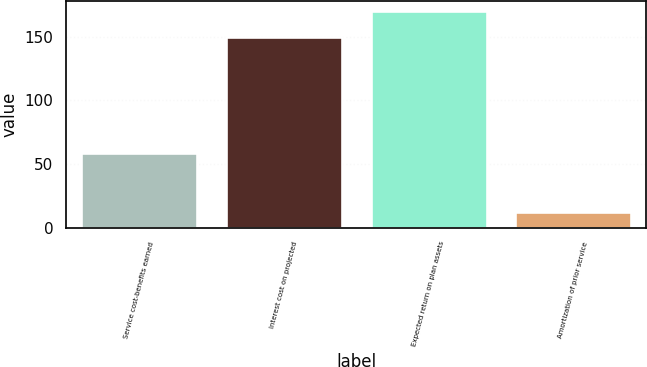<chart> <loc_0><loc_0><loc_500><loc_500><bar_chart><fcel>Service cost-benefits earned<fcel>Interest cost on projected<fcel>Expected return on plan assets<fcel>Amortization of prior service<nl><fcel>59<fcel>150<fcel>170<fcel>12<nl></chart> 